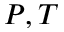Convert formula to latex. <formula><loc_0><loc_0><loc_500><loc_500>P , T</formula> 